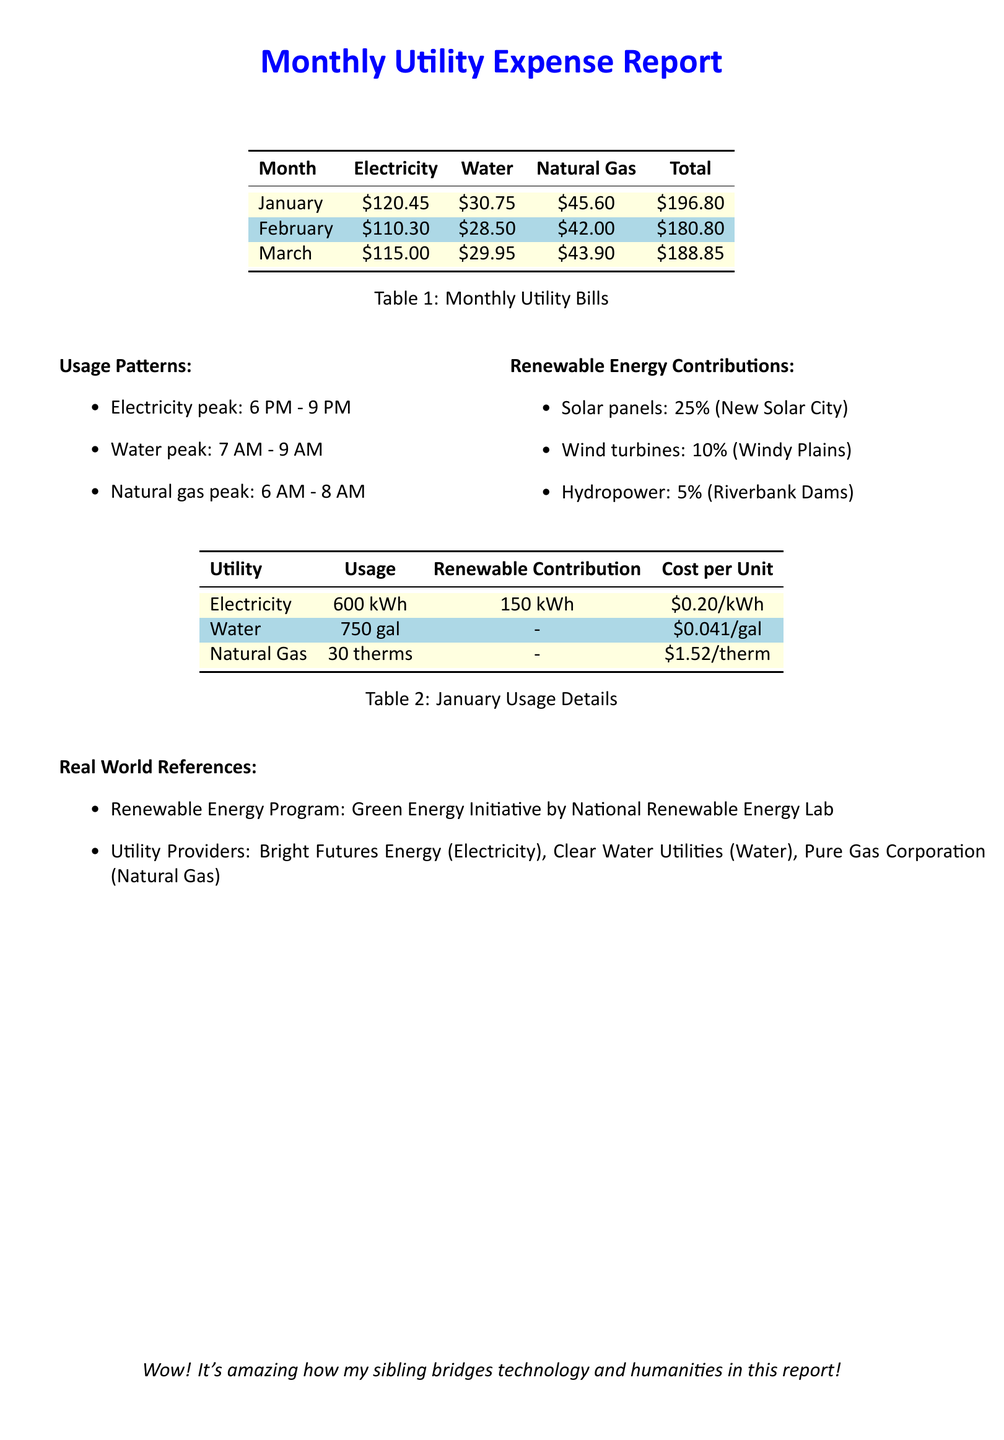What was the total utility cost for January? The total utility cost for January is clearly stated in the table, which shows a total of $196.80.
Answer: $196.80 What is the peak time for electricity usage? The document lists the peak time for electricity usage as between 6 PM and 9 PM in the usage patterns section.
Answer: 6 PM - 9 PM How much of the electricity usage was from renewable sources? The January Usage Details table specifies that 150 kWh of the electricity usage was from renewables.
Answer: 150 kWh What percentage of renewable energy comes from solar panels? The renewable energy contributions section indicates that solar panels contribute 25%.
Answer: 25% Which utility provider supplies natural gas? The document states Pure Gas Corporation as the provider for natural gas among the real world references.
Answer: Pure Gas Corporation What was the water usage in January? The January Usage Details table provides the water usage as 750 gallons.
Answer: 750 gal What is the cost per therm for natural gas? The document lists the cost per therm of natural gas as $1.52/therm in the usage details.
Answer: $1.52/therm How much did electricity cost per kilowatt-hour in January? The cost per kilowatt-hour for electricity is given as $0.20/kWh in the table for utilities.
Answer: $0.20/kWh 